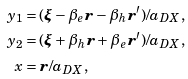Convert formula to latex. <formula><loc_0><loc_0><loc_500><loc_500>y _ { 1 } & = ( \boldsymbol \xi - \beta _ { e } \boldsymbol r - \beta _ { h } \boldsymbol r ^ { \prime } ) / a _ { D X } , \\ y _ { 2 } & = ( \boldsymbol \xi + \beta _ { h } \boldsymbol r + \beta _ { e } \boldsymbol r ^ { \prime } ) / a _ { D X } , \\ x & = \boldsymbol r / a _ { D X } ,</formula> 